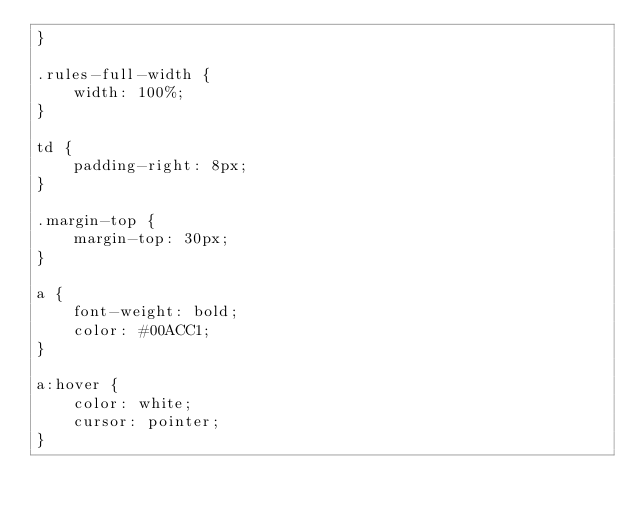<code> <loc_0><loc_0><loc_500><loc_500><_CSS_>}

.rules-full-width {
    width: 100%;
}

td {
    padding-right: 8px;
}

.margin-top {
    margin-top: 30px;
}

a {
    font-weight: bold;
    color: #00ACC1;
}

a:hover {
    color: white;
    cursor: pointer;
}</code> 